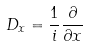Convert formula to latex. <formula><loc_0><loc_0><loc_500><loc_500>D _ { x } = \frac { 1 } { i } \frac { \partial } { \partial x }</formula> 